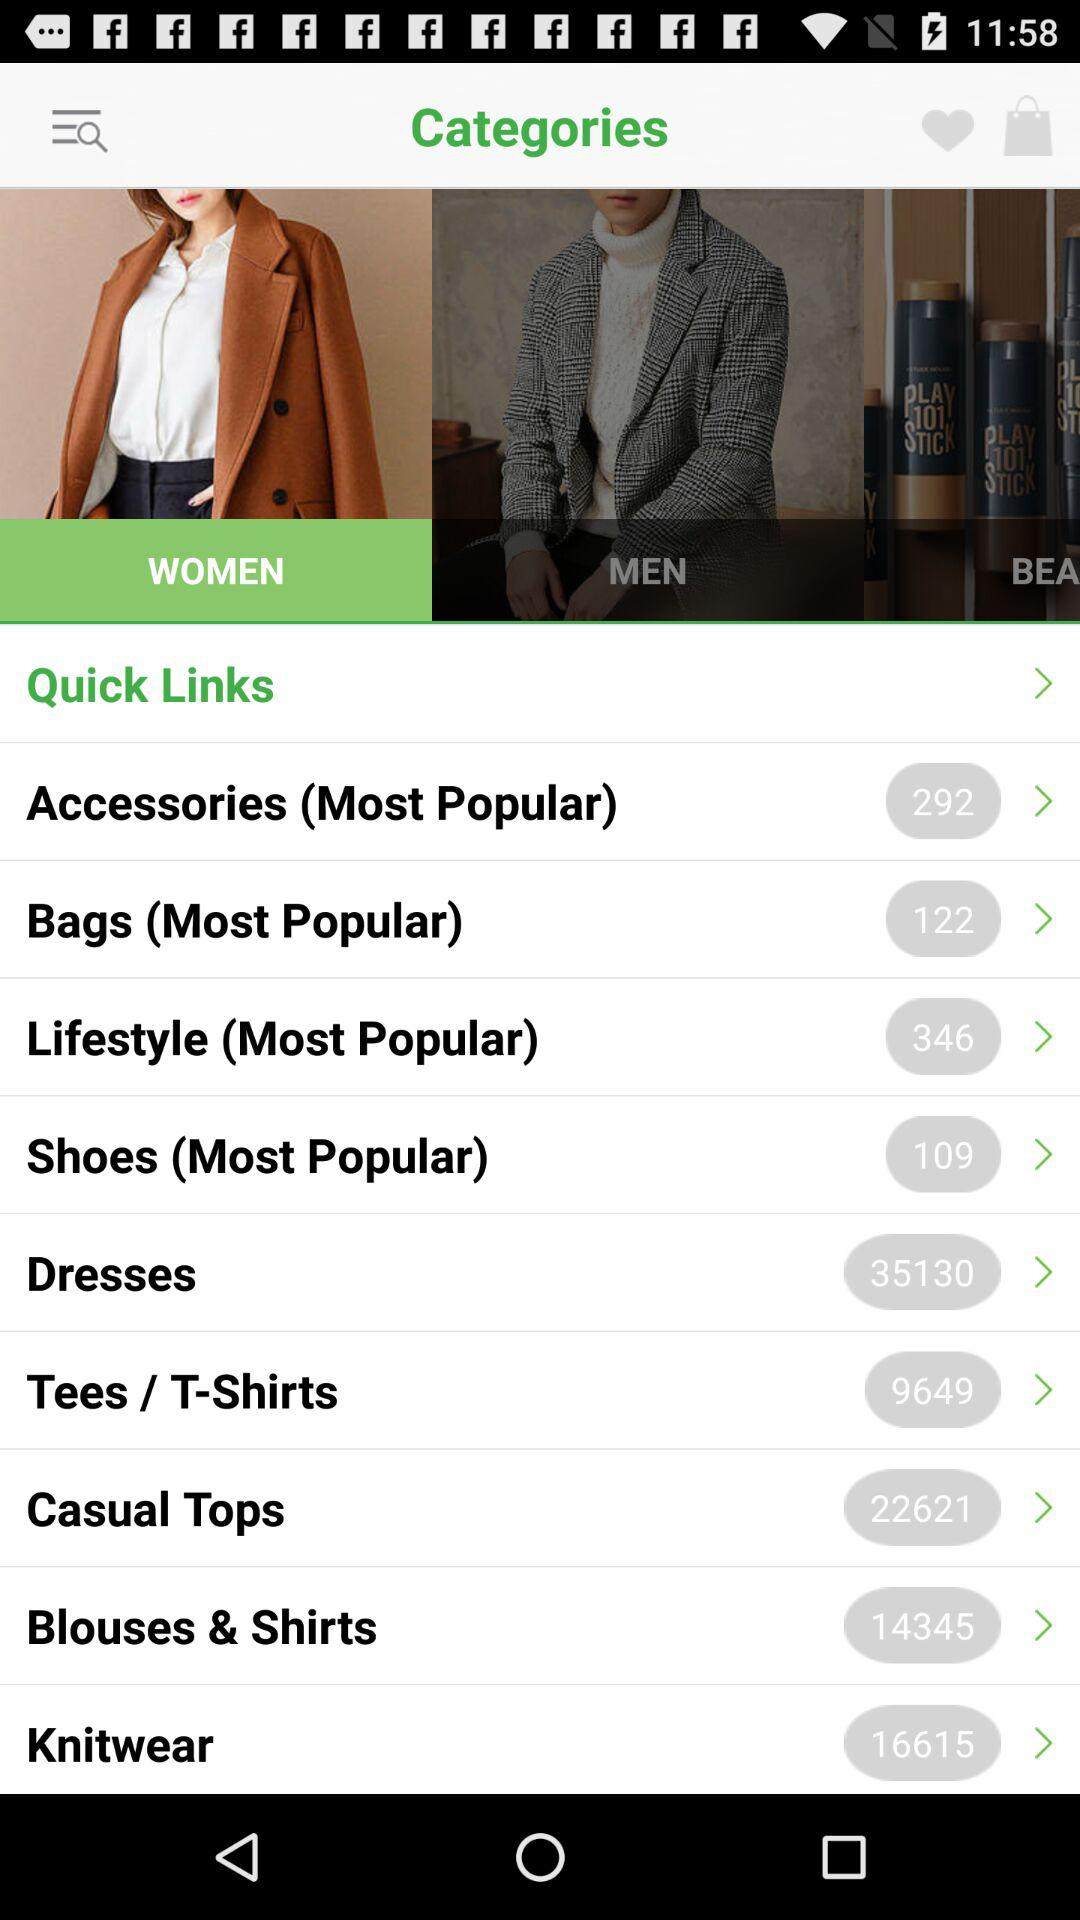How many items are in "Shoes (Most Popular)"? There are 109 items in "Shoes (Most Popular)". 